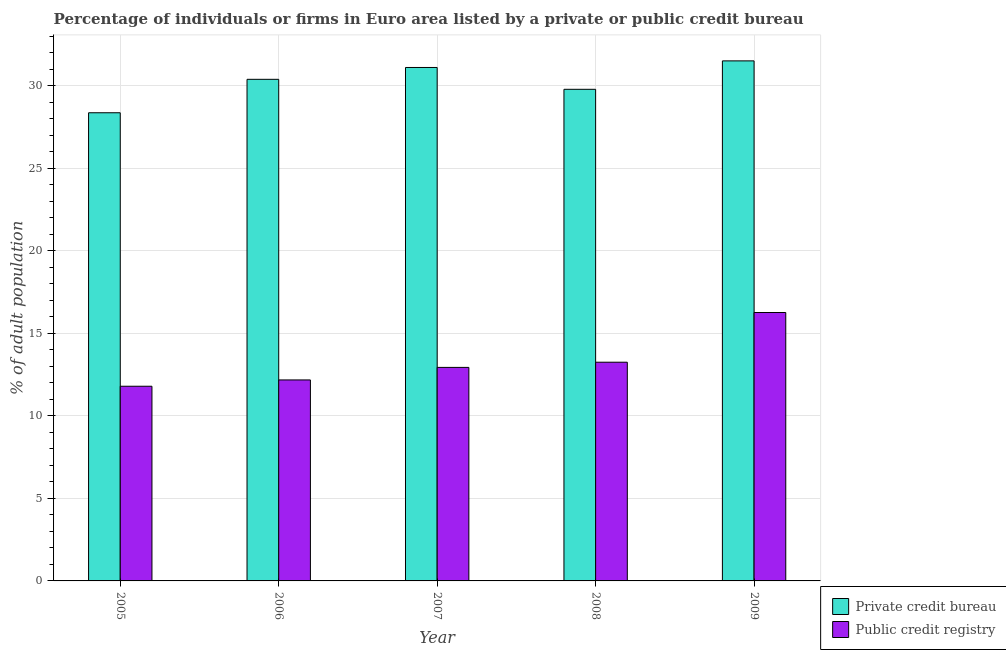How many groups of bars are there?
Provide a succinct answer. 5. How many bars are there on the 1st tick from the left?
Your response must be concise. 2. What is the label of the 3rd group of bars from the left?
Your response must be concise. 2007. What is the percentage of firms listed by public credit bureau in 2009?
Provide a succinct answer. 16.26. Across all years, what is the maximum percentage of firms listed by public credit bureau?
Your answer should be very brief. 16.26. Across all years, what is the minimum percentage of firms listed by private credit bureau?
Your answer should be very brief. 28.36. What is the total percentage of firms listed by public credit bureau in the graph?
Offer a very short reply. 66.42. What is the difference between the percentage of firms listed by public credit bureau in 2005 and that in 2007?
Ensure brevity in your answer.  -1.14. What is the difference between the percentage of firms listed by public credit bureau in 2009 and the percentage of firms listed by private credit bureau in 2006?
Make the answer very short. 4.08. What is the average percentage of firms listed by private credit bureau per year?
Your answer should be very brief. 30.23. What is the ratio of the percentage of firms listed by private credit bureau in 2005 to that in 2008?
Keep it short and to the point. 0.95. What is the difference between the highest and the second highest percentage of firms listed by public credit bureau?
Your response must be concise. 3.01. What is the difference between the highest and the lowest percentage of firms listed by private credit bureau?
Provide a succinct answer. 3.14. Is the sum of the percentage of firms listed by public credit bureau in 2005 and 2006 greater than the maximum percentage of firms listed by private credit bureau across all years?
Provide a short and direct response. Yes. What does the 1st bar from the left in 2009 represents?
Your answer should be very brief. Private credit bureau. What does the 1st bar from the right in 2005 represents?
Ensure brevity in your answer.  Public credit registry. Are all the bars in the graph horizontal?
Offer a very short reply. No. How many years are there in the graph?
Keep it short and to the point. 5. What is the difference between two consecutive major ticks on the Y-axis?
Provide a short and direct response. 5. Are the values on the major ticks of Y-axis written in scientific E-notation?
Keep it short and to the point. No. Where does the legend appear in the graph?
Your answer should be very brief. Bottom right. How many legend labels are there?
Keep it short and to the point. 2. How are the legend labels stacked?
Your answer should be compact. Vertical. What is the title of the graph?
Provide a short and direct response. Percentage of individuals or firms in Euro area listed by a private or public credit bureau. Does "Methane" appear as one of the legend labels in the graph?
Your response must be concise. No. What is the label or title of the Y-axis?
Provide a succinct answer. % of adult population. What is the % of adult population in Private credit bureau in 2005?
Your response must be concise. 28.36. What is the % of adult population in Public credit registry in 2005?
Offer a very short reply. 11.79. What is the % of adult population in Private credit bureau in 2006?
Make the answer very short. 30.39. What is the % of adult population in Public credit registry in 2006?
Provide a short and direct response. 12.18. What is the % of adult population in Private credit bureau in 2007?
Keep it short and to the point. 31.11. What is the % of adult population of Public credit registry in 2007?
Your answer should be compact. 12.94. What is the % of adult population of Private credit bureau in 2008?
Provide a succinct answer. 29.78. What is the % of adult population of Public credit registry in 2008?
Keep it short and to the point. 13.25. What is the % of adult population in Private credit bureau in 2009?
Your response must be concise. 31.51. What is the % of adult population in Public credit registry in 2009?
Make the answer very short. 16.26. Across all years, what is the maximum % of adult population of Private credit bureau?
Provide a succinct answer. 31.51. Across all years, what is the maximum % of adult population in Public credit registry?
Your answer should be very brief. 16.26. Across all years, what is the minimum % of adult population in Private credit bureau?
Offer a very short reply. 28.36. Across all years, what is the minimum % of adult population of Public credit registry?
Provide a succinct answer. 11.79. What is the total % of adult population in Private credit bureau in the graph?
Keep it short and to the point. 151.15. What is the total % of adult population in Public credit registry in the graph?
Provide a succinct answer. 66.42. What is the difference between the % of adult population in Private credit bureau in 2005 and that in 2006?
Provide a short and direct response. -2.03. What is the difference between the % of adult population of Public credit registry in 2005 and that in 2006?
Your response must be concise. -0.38. What is the difference between the % of adult population in Private credit bureau in 2005 and that in 2007?
Your answer should be compact. -2.74. What is the difference between the % of adult population in Public credit registry in 2005 and that in 2007?
Your response must be concise. -1.14. What is the difference between the % of adult population of Private credit bureau in 2005 and that in 2008?
Your answer should be compact. -1.42. What is the difference between the % of adult population in Public credit registry in 2005 and that in 2008?
Give a very brief answer. -1.46. What is the difference between the % of adult population of Private credit bureau in 2005 and that in 2009?
Your answer should be compact. -3.14. What is the difference between the % of adult population in Public credit registry in 2005 and that in 2009?
Offer a very short reply. -4.47. What is the difference between the % of adult population in Private credit bureau in 2006 and that in 2007?
Provide a short and direct response. -0.72. What is the difference between the % of adult population of Public credit registry in 2006 and that in 2007?
Provide a short and direct response. -0.76. What is the difference between the % of adult population of Private credit bureau in 2006 and that in 2008?
Give a very brief answer. 0.6. What is the difference between the % of adult population of Public credit registry in 2006 and that in 2008?
Offer a terse response. -1.07. What is the difference between the % of adult population of Private credit bureau in 2006 and that in 2009?
Give a very brief answer. -1.12. What is the difference between the % of adult population in Public credit registry in 2006 and that in 2009?
Provide a short and direct response. -4.08. What is the difference between the % of adult population of Private credit bureau in 2007 and that in 2008?
Make the answer very short. 1.32. What is the difference between the % of adult population in Public credit registry in 2007 and that in 2008?
Ensure brevity in your answer.  -0.31. What is the difference between the % of adult population of Private credit bureau in 2007 and that in 2009?
Ensure brevity in your answer.  -0.4. What is the difference between the % of adult population in Public credit registry in 2007 and that in 2009?
Ensure brevity in your answer.  -3.33. What is the difference between the % of adult population of Private credit bureau in 2008 and that in 2009?
Provide a short and direct response. -1.72. What is the difference between the % of adult population of Public credit registry in 2008 and that in 2009?
Your answer should be compact. -3.01. What is the difference between the % of adult population in Private credit bureau in 2005 and the % of adult population in Public credit registry in 2006?
Provide a succinct answer. 16.19. What is the difference between the % of adult population in Private credit bureau in 2005 and the % of adult population in Public credit registry in 2007?
Your answer should be very brief. 15.43. What is the difference between the % of adult population in Private credit bureau in 2005 and the % of adult population in Public credit registry in 2008?
Ensure brevity in your answer.  15.11. What is the difference between the % of adult population in Private credit bureau in 2005 and the % of adult population in Public credit registry in 2009?
Your response must be concise. 12.1. What is the difference between the % of adult population of Private credit bureau in 2006 and the % of adult population of Public credit registry in 2007?
Your answer should be very brief. 17.45. What is the difference between the % of adult population in Private credit bureau in 2006 and the % of adult population in Public credit registry in 2008?
Make the answer very short. 17.14. What is the difference between the % of adult population of Private credit bureau in 2006 and the % of adult population of Public credit registry in 2009?
Provide a short and direct response. 14.13. What is the difference between the % of adult population of Private credit bureau in 2007 and the % of adult population of Public credit registry in 2008?
Your answer should be compact. 17.86. What is the difference between the % of adult population of Private credit bureau in 2007 and the % of adult population of Public credit registry in 2009?
Provide a short and direct response. 14.84. What is the difference between the % of adult population in Private credit bureau in 2008 and the % of adult population in Public credit registry in 2009?
Provide a short and direct response. 13.52. What is the average % of adult population of Private credit bureau per year?
Provide a short and direct response. 30.23. What is the average % of adult population in Public credit registry per year?
Your response must be concise. 13.28. In the year 2005, what is the difference between the % of adult population of Private credit bureau and % of adult population of Public credit registry?
Make the answer very short. 16.57. In the year 2006, what is the difference between the % of adult population of Private credit bureau and % of adult population of Public credit registry?
Provide a succinct answer. 18.21. In the year 2007, what is the difference between the % of adult population of Private credit bureau and % of adult population of Public credit registry?
Your response must be concise. 18.17. In the year 2008, what is the difference between the % of adult population of Private credit bureau and % of adult population of Public credit registry?
Your response must be concise. 16.53. In the year 2009, what is the difference between the % of adult population of Private credit bureau and % of adult population of Public credit registry?
Offer a terse response. 15.24. What is the ratio of the % of adult population of Public credit registry in 2005 to that in 2006?
Keep it short and to the point. 0.97. What is the ratio of the % of adult population in Private credit bureau in 2005 to that in 2007?
Your answer should be very brief. 0.91. What is the ratio of the % of adult population of Public credit registry in 2005 to that in 2007?
Give a very brief answer. 0.91. What is the ratio of the % of adult population in Private credit bureau in 2005 to that in 2008?
Give a very brief answer. 0.95. What is the ratio of the % of adult population in Public credit registry in 2005 to that in 2008?
Offer a very short reply. 0.89. What is the ratio of the % of adult population of Private credit bureau in 2005 to that in 2009?
Keep it short and to the point. 0.9. What is the ratio of the % of adult population of Public credit registry in 2005 to that in 2009?
Your answer should be compact. 0.73. What is the ratio of the % of adult population in Private credit bureau in 2006 to that in 2007?
Your answer should be very brief. 0.98. What is the ratio of the % of adult population of Public credit registry in 2006 to that in 2007?
Your answer should be very brief. 0.94. What is the ratio of the % of adult population of Private credit bureau in 2006 to that in 2008?
Your answer should be very brief. 1.02. What is the ratio of the % of adult population in Public credit registry in 2006 to that in 2008?
Provide a short and direct response. 0.92. What is the ratio of the % of adult population in Private credit bureau in 2006 to that in 2009?
Your response must be concise. 0.96. What is the ratio of the % of adult population in Public credit registry in 2006 to that in 2009?
Your answer should be very brief. 0.75. What is the ratio of the % of adult population of Private credit bureau in 2007 to that in 2008?
Offer a very short reply. 1.04. What is the ratio of the % of adult population of Public credit registry in 2007 to that in 2008?
Provide a succinct answer. 0.98. What is the ratio of the % of adult population in Private credit bureau in 2007 to that in 2009?
Offer a terse response. 0.99. What is the ratio of the % of adult population in Public credit registry in 2007 to that in 2009?
Make the answer very short. 0.8. What is the ratio of the % of adult population in Private credit bureau in 2008 to that in 2009?
Offer a very short reply. 0.95. What is the ratio of the % of adult population of Public credit registry in 2008 to that in 2009?
Keep it short and to the point. 0.81. What is the difference between the highest and the second highest % of adult population of Private credit bureau?
Offer a terse response. 0.4. What is the difference between the highest and the second highest % of adult population in Public credit registry?
Provide a succinct answer. 3.01. What is the difference between the highest and the lowest % of adult population in Private credit bureau?
Ensure brevity in your answer.  3.14. What is the difference between the highest and the lowest % of adult population in Public credit registry?
Offer a very short reply. 4.47. 